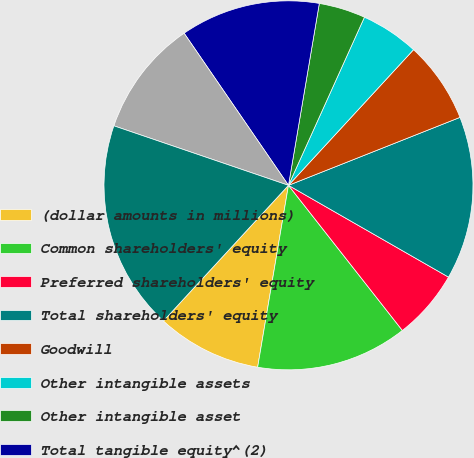<chart> <loc_0><loc_0><loc_500><loc_500><pie_chart><fcel>(dollar amounts in millions)<fcel>Common shareholders' equity<fcel>Preferred shareholders' equity<fcel>Total shareholders' equity<fcel>Goodwill<fcel>Other intangible assets<fcel>Other intangible asset<fcel>Total tangible equity^(2)<fcel>Total tangible common<fcel>Total assets<nl><fcel>9.18%<fcel>13.26%<fcel>6.12%<fcel>14.29%<fcel>7.14%<fcel>5.1%<fcel>4.08%<fcel>12.24%<fcel>10.2%<fcel>18.37%<nl></chart> 